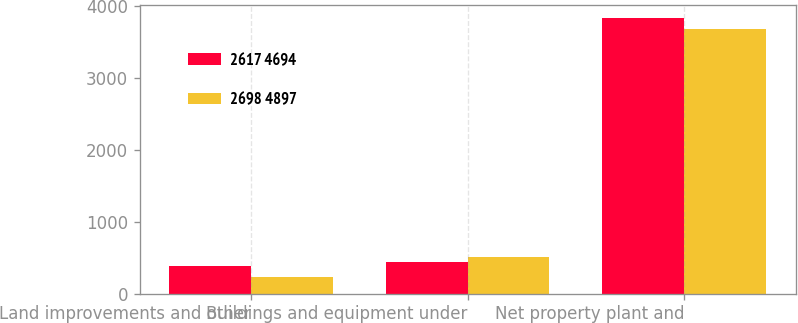Convert chart. <chart><loc_0><loc_0><loc_500><loc_500><stacked_bar_chart><ecel><fcel>Land improvements and other<fcel>Buildings and equipment under<fcel>Net property plant and<nl><fcel>2617 4694<fcel>386<fcel>446<fcel>3823<nl><fcel>2698 4897<fcel>232<fcel>513<fcel>3674<nl></chart> 